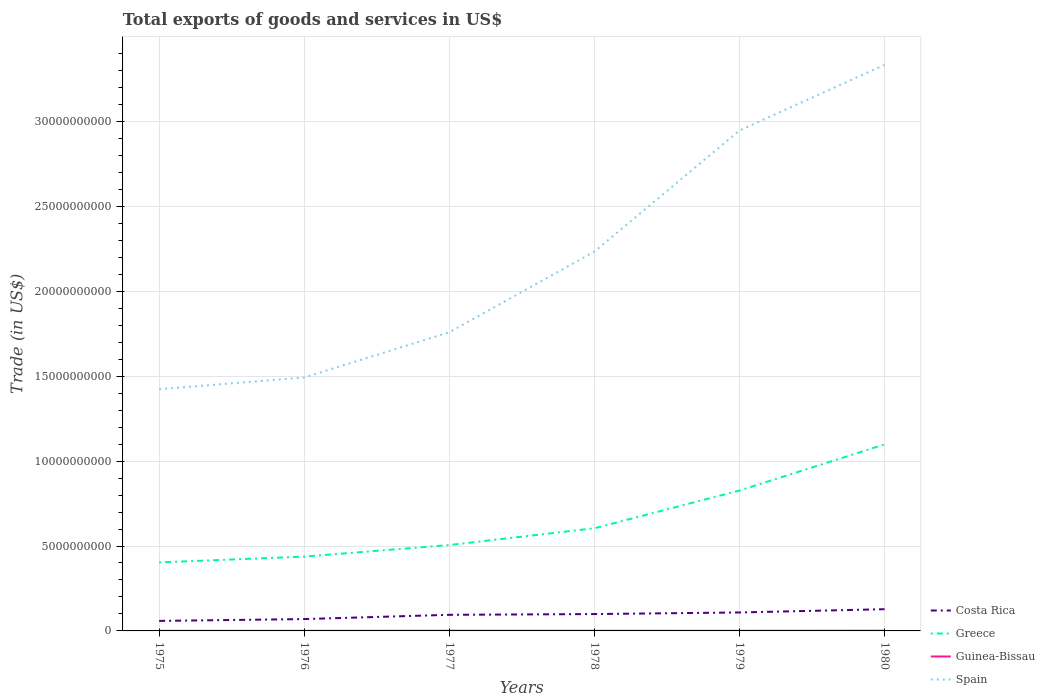Does the line corresponding to Costa Rica intersect with the line corresponding to Spain?
Provide a short and direct response. No. Across all years, what is the maximum total exports of goods and services in Costa Rica?
Offer a very short reply. 5.89e+08. In which year was the total exports of goods and services in Costa Rica maximum?
Offer a terse response. 1975. What is the total total exports of goods and services in Greece in the graph?
Provide a succinct answer. -3.43e+08. What is the difference between the highest and the second highest total exports of goods and services in Guinea-Bissau?
Your answer should be very brief. 8.39e+06. How many years are there in the graph?
Provide a short and direct response. 6. Are the values on the major ticks of Y-axis written in scientific E-notation?
Offer a very short reply. No. Does the graph contain any zero values?
Your answer should be very brief. No. Where does the legend appear in the graph?
Provide a succinct answer. Bottom right. How many legend labels are there?
Ensure brevity in your answer.  4. How are the legend labels stacked?
Provide a succinct answer. Vertical. What is the title of the graph?
Provide a short and direct response. Total exports of goods and services in US$. Does "Isle of Man" appear as one of the legend labels in the graph?
Provide a short and direct response. No. What is the label or title of the Y-axis?
Provide a short and direct response. Trade (in US$). What is the Trade (in US$) in Costa Rica in 1975?
Your answer should be very brief. 5.89e+08. What is the Trade (in US$) in Greece in 1975?
Make the answer very short. 4.03e+09. What is the Trade (in US$) in Guinea-Bissau in 1975?
Offer a terse response. 5.65e+06. What is the Trade (in US$) in Spain in 1975?
Ensure brevity in your answer.  1.42e+1. What is the Trade (in US$) of Costa Rica in 1976?
Your answer should be very brief. 6.97e+08. What is the Trade (in US$) of Greece in 1976?
Ensure brevity in your answer.  4.38e+09. What is the Trade (in US$) in Guinea-Bissau in 1976?
Your response must be concise. 5.93e+06. What is the Trade (in US$) of Spain in 1976?
Make the answer very short. 1.49e+1. What is the Trade (in US$) in Costa Rica in 1977?
Ensure brevity in your answer.  9.48e+08. What is the Trade (in US$) of Greece in 1977?
Make the answer very short. 5.06e+09. What is the Trade (in US$) of Guinea-Bissau in 1977?
Provide a short and direct response. 1.07e+07. What is the Trade (in US$) in Spain in 1977?
Ensure brevity in your answer.  1.76e+1. What is the Trade (in US$) of Costa Rica in 1978?
Your answer should be very brief. 9.93e+08. What is the Trade (in US$) of Greece in 1978?
Keep it short and to the point. 6.04e+09. What is the Trade (in US$) of Guinea-Bissau in 1978?
Provide a short and direct response. 9.49e+06. What is the Trade (in US$) of Spain in 1978?
Offer a terse response. 2.23e+1. What is the Trade (in US$) of Costa Rica in 1979?
Keep it short and to the point. 1.09e+09. What is the Trade (in US$) in Greece in 1979?
Offer a very short reply. 8.27e+09. What is the Trade (in US$) in Guinea-Bissau in 1979?
Offer a terse response. 8.62e+06. What is the Trade (in US$) of Spain in 1979?
Keep it short and to the point. 2.95e+1. What is the Trade (in US$) of Costa Rica in 1980?
Provide a succinct answer. 1.28e+09. What is the Trade (in US$) in Greece in 1980?
Provide a succinct answer. 1.10e+1. What is the Trade (in US$) in Guinea-Bissau in 1980?
Ensure brevity in your answer.  1.40e+07. What is the Trade (in US$) of Spain in 1980?
Your answer should be compact. 3.33e+1. Across all years, what is the maximum Trade (in US$) in Costa Rica?
Your response must be concise. 1.28e+09. Across all years, what is the maximum Trade (in US$) of Greece?
Provide a succinct answer. 1.10e+1. Across all years, what is the maximum Trade (in US$) in Guinea-Bissau?
Make the answer very short. 1.40e+07. Across all years, what is the maximum Trade (in US$) in Spain?
Ensure brevity in your answer.  3.33e+1. Across all years, what is the minimum Trade (in US$) of Costa Rica?
Ensure brevity in your answer.  5.89e+08. Across all years, what is the minimum Trade (in US$) of Greece?
Your answer should be compact. 4.03e+09. Across all years, what is the minimum Trade (in US$) of Guinea-Bissau?
Keep it short and to the point. 5.65e+06. Across all years, what is the minimum Trade (in US$) of Spain?
Your answer should be compact. 1.42e+1. What is the total Trade (in US$) in Costa Rica in the graph?
Your answer should be very brief. 5.59e+09. What is the total Trade (in US$) in Greece in the graph?
Give a very brief answer. 3.88e+1. What is the total Trade (in US$) in Guinea-Bissau in the graph?
Provide a succinct answer. 5.44e+07. What is the total Trade (in US$) in Spain in the graph?
Provide a succinct answer. 1.32e+11. What is the difference between the Trade (in US$) of Costa Rica in 1975 and that in 1976?
Give a very brief answer. -1.08e+08. What is the difference between the Trade (in US$) of Greece in 1975 and that in 1976?
Provide a succinct answer. -3.43e+08. What is the difference between the Trade (in US$) in Guinea-Bissau in 1975 and that in 1976?
Make the answer very short. -2.75e+05. What is the difference between the Trade (in US$) of Spain in 1975 and that in 1976?
Give a very brief answer. -6.89e+08. What is the difference between the Trade (in US$) in Costa Rica in 1975 and that in 1977?
Keep it short and to the point. -3.59e+08. What is the difference between the Trade (in US$) in Greece in 1975 and that in 1977?
Offer a terse response. -1.02e+09. What is the difference between the Trade (in US$) of Guinea-Bissau in 1975 and that in 1977?
Your response must be concise. -5.05e+06. What is the difference between the Trade (in US$) in Spain in 1975 and that in 1977?
Offer a terse response. -3.35e+09. What is the difference between the Trade (in US$) in Costa Rica in 1975 and that in 1978?
Keep it short and to the point. -4.03e+08. What is the difference between the Trade (in US$) in Greece in 1975 and that in 1978?
Provide a succinct answer. -2.01e+09. What is the difference between the Trade (in US$) in Guinea-Bissau in 1975 and that in 1978?
Your answer should be very brief. -3.84e+06. What is the difference between the Trade (in US$) in Spain in 1975 and that in 1978?
Provide a short and direct response. -8.10e+09. What is the difference between the Trade (in US$) of Costa Rica in 1975 and that in 1979?
Offer a terse response. -4.97e+08. What is the difference between the Trade (in US$) in Greece in 1975 and that in 1979?
Provide a short and direct response. -4.23e+09. What is the difference between the Trade (in US$) of Guinea-Bissau in 1975 and that in 1979?
Offer a very short reply. -2.97e+06. What is the difference between the Trade (in US$) in Spain in 1975 and that in 1979?
Provide a short and direct response. -1.52e+1. What is the difference between the Trade (in US$) of Costa Rica in 1975 and that in 1980?
Offer a terse response. -6.90e+08. What is the difference between the Trade (in US$) in Greece in 1975 and that in 1980?
Keep it short and to the point. -6.95e+09. What is the difference between the Trade (in US$) of Guinea-Bissau in 1975 and that in 1980?
Provide a succinct answer. -8.39e+06. What is the difference between the Trade (in US$) of Spain in 1975 and that in 1980?
Your answer should be compact. -1.91e+1. What is the difference between the Trade (in US$) of Costa Rica in 1976 and that in 1977?
Provide a short and direct response. -2.51e+08. What is the difference between the Trade (in US$) of Greece in 1976 and that in 1977?
Offer a very short reply. -6.81e+08. What is the difference between the Trade (in US$) of Guinea-Bissau in 1976 and that in 1977?
Provide a succinct answer. -4.77e+06. What is the difference between the Trade (in US$) in Spain in 1976 and that in 1977?
Provide a short and direct response. -2.66e+09. What is the difference between the Trade (in US$) in Costa Rica in 1976 and that in 1978?
Provide a succinct answer. -2.95e+08. What is the difference between the Trade (in US$) in Greece in 1976 and that in 1978?
Offer a terse response. -1.67e+09. What is the difference between the Trade (in US$) of Guinea-Bissau in 1976 and that in 1978?
Give a very brief answer. -3.56e+06. What is the difference between the Trade (in US$) of Spain in 1976 and that in 1978?
Provide a succinct answer. -7.41e+09. What is the difference between the Trade (in US$) of Costa Rica in 1976 and that in 1979?
Your response must be concise. -3.89e+08. What is the difference between the Trade (in US$) in Greece in 1976 and that in 1979?
Your answer should be very brief. -3.89e+09. What is the difference between the Trade (in US$) of Guinea-Bissau in 1976 and that in 1979?
Offer a terse response. -2.69e+06. What is the difference between the Trade (in US$) in Spain in 1976 and that in 1979?
Ensure brevity in your answer.  -1.45e+1. What is the difference between the Trade (in US$) of Costa Rica in 1976 and that in 1980?
Your answer should be compact. -5.82e+08. What is the difference between the Trade (in US$) of Greece in 1976 and that in 1980?
Offer a very short reply. -6.61e+09. What is the difference between the Trade (in US$) of Guinea-Bissau in 1976 and that in 1980?
Keep it short and to the point. -8.11e+06. What is the difference between the Trade (in US$) in Spain in 1976 and that in 1980?
Make the answer very short. -1.84e+1. What is the difference between the Trade (in US$) in Costa Rica in 1977 and that in 1978?
Give a very brief answer. -4.45e+07. What is the difference between the Trade (in US$) in Greece in 1977 and that in 1978?
Your answer should be compact. -9.87e+08. What is the difference between the Trade (in US$) of Guinea-Bissau in 1977 and that in 1978?
Keep it short and to the point. 1.21e+06. What is the difference between the Trade (in US$) in Spain in 1977 and that in 1978?
Make the answer very short. -4.75e+09. What is the difference between the Trade (in US$) of Costa Rica in 1977 and that in 1979?
Offer a terse response. -1.38e+08. What is the difference between the Trade (in US$) in Greece in 1977 and that in 1979?
Your answer should be compact. -3.21e+09. What is the difference between the Trade (in US$) of Guinea-Bissau in 1977 and that in 1979?
Make the answer very short. 2.08e+06. What is the difference between the Trade (in US$) in Spain in 1977 and that in 1979?
Give a very brief answer. -1.19e+1. What is the difference between the Trade (in US$) in Costa Rica in 1977 and that in 1980?
Your answer should be very brief. -3.31e+08. What is the difference between the Trade (in US$) in Greece in 1977 and that in 1980?
Your answer should be very brief. -5.92e+09. What is the difference between the Trade (in US$) of Guinea-Bissau in 1977 and that in 1980?
Provide a succinct answer. -3.34e+06. What is the difference between the Trade (in US$) of Spain in 1977 and that in 1980?
Make the answer very short. -1.57e+1. What is the difference between the Trade (in US$) in Costa Rica in 1978 and that in 1979?
Your response must be concise. -9.36e+07. What is the difference between the Trade (in US$) in Greece in 1978 and that in 1979?
Your answer should be compact. -2.22e+09. What is the difference between the Trade (in US$) of Guinea-Bissau in 1978 and that in 1979?
Ensure brevity in your answer.  8.68e+05. What is the difference between the Trade (in US$) of Spain in 1978 and that in 1979?
Offer a very short reply. -7.13e+09. What is the difference between the Trade (in US$) in Costa Rica in 1978 and that in 1980?
Provide a succinct answer. -2.86e+08. What is the difference between the Trade (in US$) of Greece in 1978 and that in 1980?
Your response must be concise. -4.94e+09. What is the difference between the Trade (in US$) of Guinea-Bissau in 1978 and that in 1980?
Give a very brief answer. -4.55e+06. What is the difference between the Trade (in US$) of Spain in 1978 and that in 1980?
Your response must be concise. -1.10e+1. What is the difference between the Trade (in US$) in Costa Rica in 1979 and that in 1980?
Your answer should be compact. -1.93e+08. What is the difference between the Trade (in US$) of Greece in 1979 and that in 1980?
Your answer should be compact. -2.71e+09. What is the difference between the Trade (in US$) in Guinea-Bissau in 1979 and that in 1980?
Your answer should be very brief. -5.42e+06. What is the difference between the Trade (in US$) in Spain in 1979 and that in 1980?
Provide a succinct answer. -3.86e+09. What is the difference between the Trade (in US$) in Costa Rica in 1975 and the Trade (in US$) in Greece in 1976?
Your answer should be compact. -3.79e+09. What is the difference between the Trade (in US$) of Costa Rica in 1975 and the Trade (in US$) of Guinea-Bissau in 1976?
Your answer should be very brief. 5.84e+08. What is the difference between the Trade (in US$) in Costa Rica in 1975 and the Trade (in US$) in Spain in 1976?
Keep it short and to the point. -1.43e+1. What is the difference between the Trade (in US$) in Greece in 1975 and the Trade (in US$) in Guinea-Bissau in 1976?
Offer a terse response. 4.03e+09. What is the difference between the Trade (in US$) in Greece in 1975 and the Trade (in US$) in Spain in 1976?
Offer a very short reply. -1.09e+1. What is the difference between the Trade (in US$) in Guinea-Bissau in 1975 and the Trade (in US$) in Spain in 1976?
Give a very brief answer. -1.49e+1. What is the difference between the Trade (in US$) of Costa Rica in 1975 and the Trade (in US$) of Greece in 1977?
Offer a very short reply. -4.47e+09. What is the difference between the Trade (in US$) of Costa Rica in 1975 and the Trade (in US$) of Guinea-Bissau in 1977?
Your answer should be very brief. 5.79e+08. What is the difference between the Trade (in US$) in Costa Rica in 1975 and the Trade (in US$) in Spain in 1977?
Make the answer very short. -1.70e+1. What is the difference between the Trade (in US$) in Greece in 1975 and the Trade (in US$) in Guinea-Bissau in 1977?
Offer a terse response. 4.02e+09. What is the difference between the Trade (in US$) of Greece in 1975 and the Trade (in US$) of Spain in 1977?
Give a very brief answer. -1.36e+1. What is the difference between the Trade (in US$) of Guinea-Bissau in 1975 and the Trade (in US$) of Spain in 1977?
Provide a short and direct response. -1.76e+1. What is the difference between the Trade (in US$) of Costa Rica in 1975 and the Trade (in US$) of Greece in 1978?
Offer a terse response. -5.45e+09. What is the difference between the Trade (in US$) in Costa Rica in 1975 and the Trade (in US$) in Guinea-Bissau in 1978?
Your answer should be very brief. 5.80e+08. What is the difference between the Trade (in US$) in Costa Rica in 1975 and the Trade (in US$) in Spain in 1978?
Make the answer very short. -2.17e+1. What is the difference between the Trade (in US$) of Greece in 1975 and the Trade (in US$) of Guinea-Bissau in 1978?
Your answer should be very brief. 4.02e+09. What is the difference between the Trade (in US$) in Greece in 1975 and the Trade (in US$) in Spain in 1978?
Offer a very short reply. -1.83e+1. What is the difference between the Trade (in US$) in Guinea-Bissau in 1975 and the Trade (in US$) in Spain in 1978?
Keep it short and to the point. -2.23e+1. What is the difference between the Trade (in US$) of Costa Rica in 1975 and the Trade (in US$) of Greece in 1979?
Offer a very short reply. -7.68e+09. What is the difference between the Trade (in US$) in Costa Rica in 1975 and the Trade (in US$) in Guinea-Bissau in 1979?
Your answer should be compact. 5.81e+08. What is the difference between the Trade (in US$) of Costa Rica in 1975 and the Trade (in US$) of Spain in 1979?
Provide a short and direct response. -2.89e+1. What is the difference between the Trade (in US$) in Greece in 1975 and the Trade (in US$) in Guinea-Bissau in 1979?
Offer a very short reply. 4.03e+09. What is the difference between the Trade (in US$) of Greece in 1975 and the Trade (in US$) of Spain in 1979?
Give a very brief answer. -2.54e+1. What is the difference between the Trade (in US$) of Guinea-Bissau in 1975 and the Trade (in US$) of Spain in 1979?
Provide a short and direct response. -2.95e+1. What is the difference between the Trade (in US$) in Costa Rica in 1975 and the Trade (in US$) in Greece in 1980?
Provide a short and direct response. -1.04e+1. What is the difference between the Trade (in US$) of Costa Rica in 1975 and the Trade (in US$) of Guinea-Bissau in 1980?
Your response must be concise. 5.75e+08. What is the difference between the Trade (in US$) of Costa Rica in 1975 and the Trade (in US$) of Spain in 1980?
Provide a short and direct response. -3.27e+1. What is the difference between the Trade (in US$) in Greece in 1975 and the Trade (in US$) in Guinea-Bissau in 1980?
Provide a short and direct response. 4.02e+09. What is the difference between the Trade (in US$) of Greece in 1975 and the Trade (in US$) of Spain in 1980?
Give a very brief answer. -2.93e+1. What is the difference between the Trade (in US$) in Guinea-Bissau in 1975 and the Trade (in US$) in Spain in 1980?
Your answer should be very brief. -3.33e+1. What is the difference between the Trade (in US$) in Costa Rica in 1976 and the Trade (in US$) in Greece in 1977?
Your answer should be very brief. -4.36e+09. What is the difference between the Trade (in US$) in Costa Rica in 1976 and the Trade (in US$) in Guinea-Bissau in 1977?
Offer a very short reply. 6.87e+08. What is the difference between the Trade (in US$) of Costa Rica in 1976 and the Trade (in US$) of Spain in 1977?
Offer a very short reply. -1.69e+1. What is the difference between the Trade (in US$) in Greece in 1976 and the Trade (in US$) in Guinea-Bissau in 1977?
Give a very brief answer. 4.37e+09. What is the difference between the Trade (in US$) of Greece in 1976 and the Trade (in US$) of Spain in 1977?
Make the answer very short. -1.32e+1. What is the difference between the Trade (in US$) of Guinea-Bissau in 1976 and the Trade (in US$) of Spain in 1977?
Ensure brevity in your answer.  -1.76e+1. What is the difference between the Trade (in US$) in Costa Rica in 1976 and the Trade (in US$) in Greece in 1978?
Make the answer very short. -5.35e+09. What is the difference between the Trade (in US$) in Costa Rica in 1976 and the Trade (in US$) in Guinea-Bissau in 1978?
Keep it short and to the point. 6.88e+08. What is the difference between the Trade (in US$) of Costa Rica in 1976 and the Trade (in US$) of Spain in 1978?
Offer a very short reply. -2.16e+1. What is the difference between the Trade (in US$) in Greece in 1976 and the Trade (in US$) in Guinea-Bissau in 1978?
Keep it short and to the point. 4.37e+09. What is the difference between the Trade (in US$) in Greece in 1976 and the Trade (in US$) in Spain in 1978?
Your answer should be very brief. -1.80e+1. What is the difference between the Trade (in US$) in Guinea-Bissau in 1976 and the Trade (in US$) in Spain in 1978?
Your answer should be very brief. -2.23e+1. What is the difference between the Trade (in US$) in Costa Rica in 1976 and the Trade (in US$) in Greece in 1979?
Provide a succinct answer. -7.57e+09. What is the difference between the Trade (in US$) in Costa Rica in 1976 and the Trade (in US$) in Guinea-Bissau in 1979?
Offer a terse response. 6.89e+08. What is the difference between the Trade (in US$) in Costa Rica in 1976 and the Trade (in US$) in Spain in 1979?
Keep it short and to the point. -2.88e+1. What is the difference between the Trade (in US$) in Greece in 1976 and the Trade (in US$) in Guinea-Bissau in 1979?
Make the answer very short. 4.37e+09. What is the difference between the Trade (in US$) in Greece in 1976 and the Trade (in US$) in Spain in 1979?
Your answer should be compact. -2.51e+1. What is the difference between the Trade (in US$) in Guinea-Bissau in 1976 and the Trade (in US$) in Spain in 1979?
Your answer should be compact. -2.95e+1. What is the difference between the Trade (in US$) of Costa Rica in 1976 and the Trade (in US$) of Greece in 1980?
Provide a succinct answer. -1.03e+1. What is the difference between the Trade (in US$) in Costa Rica in 1976 and the Trade (in US$) in Guinea-Bissau in 1980?
Provide a succinct answer. 6.83e+08. What is the difference between the Trade (in US$) of Costa Rica in 1976 and the Trade (in US$) of Spain in 1980?
Your answer should be very brief. -3.26e+1. What is the difference between the Trade (in US$) of Greece in 1976 and the Trade (in US$) of Guinea-Bissau in 1980?
Offer a terse response. 4.36e+09. What is the difference between the Trade (in US$) in Greece in 1976 and the Trade (in US$) in Spain in 1980?
Your answer should be compact. -2.90e+1. What is the difference between the Trade (in US$) of Guinea-Bissau in 1976 and the Trade (in US$) of Spain in 1980?
Your response must be concise. -3.33e+1. What is the difference between the Trade (in US$) in Costa Rica in 1977 and the Trade (in US$) in Greece in 1978?
Your response must be concise. -5.10e+09. What is the difference between the Trade (in US$) in Costa Rica in 1977 and the Trade (in US$) in Guinea-Bissau in 1978?
Make the answer very short. 9.39e+08. What is the difference between the Trade (in US$) of Costa Rica in 1977 and the Trade (in US$) of Spain in 1978?
Provide a short and direct response. -2.14e+1. What is the difference between the Trade (in US$) of Greece in 1977 and the Trade (in US$) of Guinea-Bissau in 1978?
Give a very brief answer. 5.05e+09. What is the difference between the Trade (in US$) of Greece in 1977 and the Trade (in US$) of Spain in 1978?
Give a very brief answer. -1.73e+1. What is the difference between the Trade (in US$) of Guinea-Bissau in 1977 and the Trade (in US$) of Spain in 1978?
Offer a very short reply. -2.23e+1. What is the difference between the Trade (in US$) of Costa Rica in 1977 and the Trade (in US$) of Greece in 1979?
Give a very brief answer. -7.32e+09. What is the difference between the Trade (in US$) of Costa Rica in 1977 and the Trade (in US$) of Guinea-Bissau in 1979?
Your answer should be compact. 9.40e+08. What is the difference between the Trade (in US$) in Costa Rica in 1977 and the Trade (in US$) in Spain in 1979?
Your response must be concise. -2.85e+1. What is the difference between the Trade (in US$) in Greece in 1977 and the Trade (in US$) in Guinea-Bissau in 1979?
Ensure brevity in your answer.  5.05e+09. What is the difference between the Trade (in US$) of Greece in 1977 and the Trade (in US$) of Spain in 1979?
Your response must be concise. -2.44e+1. What is the difference between the Trade (in US$) in Guinea-Bissau in 1977 and the Trade (in US$) in Spain in 1979?
Give a very brief answer. -2.95e+1. What is the difference between the Trade (in US$) in Costa Rica in 1977 and the Trade (in US$) in Greece in 1980?
Provide a succinct answer. -1.00e+1. What is the difference between the Trade (in US$) of Costa Rica in 1977 and the Trade (in US$) of Guinea-Bissau in 1980?
Give a very brief answer. 9.34e+08. What is the difference between the Trade (in US$) in Costa Rica in 1977 and the Trade (in US$) in Spain in 1980?
Your answer should be compact. -3.24e+1. What is the difference between the Trade (in US$) of Greece in 1977 and the Trade (in US$) of Guinea-Bissau in 1980?
Provide a short and direct response. 5.04e+09. What is the difference between the Trade (in US$) in Greece in 1977 and the Trade (in US$) in Spain in 1980?
Offer a terse response. -2.83e+1. What is the difference between the Trade (in US$) in Guinea-Bissau in 1977 and the Trade (in US$) in Spain in 1980?
Ensure brevity in your answer.  -3.33e+1. What is the difference between the Trade (in US$) of Costa Rica in 1978 and the Trade (in US$) of Greece in 1979?
Your answer should be compact. -7.27e+09. What is the difference between the Trade (in US$) in Costa Rica in 1978 and the Trade (in US$) in Guinea-Bissau in 1979?
Ensure brevity in your answer.  9.84e+08. What is the difference between the Trade (in US$) of Costa Rica in 1978 and the Trade (in US$) of Spain in 1979?
Your response must be concise. -2.85e+1. What is the difference between the Trade (in US$) of Greece in 1978 and the Trade (in US$) of Guinea-Bissau in 1979?
Ensure brevity in your answer.  6.04e+09. What is the difference between the Trade (in US$) of Greece in 1978 and the Trade (in US$) of Spain in 1979?
Provide a succinct answer. -2.34e+1. What is the difference between the Trade (in US$) of Guinea-Bissau in 1978 and the Trade (in US$) of Spain in 1979?
Provide a short and direct response. -2.95e+1. What is the difference between the Trade (in US$) in Costa Rica in 1978 and the Trade (in US$) in Greece in 1980?
Your answer should be very brief. -9.99e+09. What is the difference between the Trade (in US$) of Costa Rica in 1978 and the Trade (in US$) of Guinea-Bissau in 1980?
Offer a very short reply. 9.79e+08. What is the difference between the Trade (in US$) in Costa Rica in 1978 and the Trade (in US$) in Spain in 1980?
Offer a very short reply. -3.23e+1. What is the difference between the Trade (in US$) in Greece in 1978 and the Trade (in US$) in Guinea-Bissau in 1980?
Your response must be concise. 6.03e+09. What is the difference between the Trade (in US$) in Greece in 1978 and the Trade (in US$) in Spain in 1980?
Your response must be concise. -2.73e+1. What is the difference between the Trade (in US$) in Guinea-Bissau in 1978 and the Trade (in US$) in Spain in 1980?
Keep it short and to the point. -3.33e+1. What is the difference between the Trade (in US$) of Costa Rica in 1979 and the Trade (in US$) of Greece in 1980?
Your response must be concise. -9.90e+09. What is the difference between the Trade (in US$) of Costa Rica in 1979 and the Trade (in US$) of Guinea-Bissau in 1980?
Give a very brief answer. 1.07e+09. What is the difference between the Trade (in US$) in Costa Rica in 1979 and the Trade (in US$) in Spain in 1980?
Provide a short and direct response. -3.22e+1. What is the difference between the Trade (in US$) in Greece in 1979 and the Trade (in US$) in Guinea-Bissau in 1980?
Give a very brief answer. 8.25e+09. What is the difference between the Trade (in US$) of Greece in 1979 and the Trade (in US$) of Spain in 1980?
Offer a terse response. -2.51e+1. What is the difference between the Trade (in US$) in Guinea-Bissau in 1979 and the Trade (in US$) in Spain in 1980?
Make the answer very short. -3.33e+1. What is the average Trade (in US$) in Costa Rica per year?
Offer a terse response. 9.32e+08. What is the average Trade (in US$) in Greece per year?
Your answer should be compact. 6.46e+09. What is the average Trade (in US$) of Guinea-Bissau per year?
Your response must be concise. 9.07e+06. What is the average Trade (in US$) in Spain per year?
Your response must be concise. 2.20e+1. In the year 1975, what is the difference between the Trade (in US$) in Costa Rica and Trade (in US$) in Greece?
Your response must be concise. -3.44e+09. In the year 1975, what is the difference between the Trade (in US$) in Costa Rica and Trade (in US$) in Guinea-Bissau?
Your answer should be very brief. 5.84e+08. In the year 1975, what is the difference between the Trade (in US$) of Costa Rica and Trade (in US$) of Spain?
Offer a very short reply. -1.36e+1. In the year 1975, what is the difference between the Trade (in US$) of Greece and Trade (in US$) of Guinea-Bissau?
Your response must be concise. 4.03e+09. In the year 1975, what is the difference between the Trade (in US$) of Greece and Trade (in US$) of Spain?
Provide a short and direct response. -1.02e+1. In the year 1975, what is the difference between the Trade (in US$) of Guinea-Bissau and Trade (in US$) of Spain?
Keep it short and to the point. -1.42e+1. In the year 1976, what is the difference between the Trade (in US$) in Costa Rica and Trade (in US$) in Greece?
Keep it short and to the point. -3.68e+09. In the year 1976, what is the difference between the Trade (in US$) of Costa Rica and Trade (in US$) of Guinea-Bissau?
Give a very brief answer. 6.92e+08. In the year 1976, what is the difference between the Trade (in US$) of Costa Rica and Trade (in US$) of Spain?
Provide a short and direct response. -1.42e+1. In the year 1976, what is the difference between the Trade (in US$) in Greece and Trade (in US$) in Guinea-Bissau?
Your response must be concise. 4.37e+09. In the year 1976, what is the difference between the Trade (in US$) of Greece and Trade (in US$) of Spain?
Offer a terse response. -1.05e+1. In the year 1976, what is the difference between the Trade (in US$) of Guinea-Bissau and Trade (in US$) of Spain?
Provide a short and direct response. -1.49e+1. In the year 1977, what is the difference between the Trade (in US$) of Costa Rica and Trade (in US$) of Greece?
Ensure brevity in your answer.  -4.11e+09. In the year 1977, what is the difference between the Trade (in US$) in Costa Rica and Trade (in US$) in Guinea-Bissau?
Provide a succinct answer. 9.38e+08. In the year 1977, what is the difference between the Trade (in US$) of Costa Rica and Trade (in US$) of Spain?
Provide a succinct answer. -1.66e+1. In the year 1977, what is the difference between the Trade (in US$) of Greece and Trade (in US$) of Guinea-Bissau?
Provide a succinct answer. 5.05e+09. In the year 1977, what is the difference between the Trade (in US$) in Greece and Trade (in US$) in Spain?
Make the answer very short. -1.25e+1. In the year 1977, what is the difference between the Trade (in US$) in Guinea-Bissau and Trade (in US$) in Spain?
Your response must be concise. -1.76e+1. In the year 1978, what is the difference between the Trade (in US$) of Costa Rica and Trade (in US$) of Greece?
Your response must be concise. -5.05e+09. In the year 1978, what is the difference between the Trade (in US$) in Costa Rica and Trade (in US$) in Guinea-Bissau?
Provide a succinct answer. 9.83e+08. In the year 1978, what is the difference between the Trade (in US$) of Costa Rica and Trade (in US$) of Spain?
Keep it short and to the point. -2.13e+1. In the year 1978, what is the difference between the Trade (in US$) of Greece and Trade (in US$) of Guinea-Bissau?
Your response must be concise. 6.03e+09. In the year 1978, what is the difference between the Trade (in US$) of Greece and Trade (in US$) of Spain?
Your response must be concise. -1.63e+1. In the year 1978, what is the difference between the Trade (in US$) of Guinea-Bissau and Trade (in US$) of Spain?
Provide a succinct answer. -2.23e+1. In the year 1979, what is the difference between the Trade (in US$) in Costa Rica and Trade (in US$) in Greece?
Offer a terse response. -7.18e+09. In the year 1979, what is the difference between the Trade (in US$) in Costa Rica and Trade (in US$) in Guinea-Bissau?
Provide a succinct answer. 1.08e+09. In the year 1979, what is the difference between the Trade (in US$) of Costa Rica and Trade (in US$) of Spain?
Your answer should be very brief. -2.84e+1. In the year 1979, what is the difference between the Trade (in US$) in Greece and Trade (in US$) in Guinea-Bissau?
Offer a terse response. 8.26e+09. In the year 1979, what is the difference between the Trade (in US$) in Greece and Trade (in US$) in Spain?
Provide a short and direct response. -2.12e+1. In the year 1979, what is the difference between the Trade (in US$) of Guinea-Bissau and Trade (in US$) of Spain?
Your response must be concise. -2.95e+1. In the year 1980, what is the difference between the Trade (in US$) of Costa Rica and Trade (in US$) of Greece?
Offer a terse response. -9.70e+09. In the year 1980, what is the difference between the Trade (in US$) of Costa Rica and Trade (in US$) of Guinea-Bissau?
Your response must be concise. 1.27e+09. In the year 1980, what is the difference between the Trade (in US$) in Costa Rica and Trade (in US$) in Spain?
Offer a very short reply. -3.21e+1. In the year 1980, what is the difference between the Trade (in US$) in Greece and Trade (in US$) in Guinea-Bissau?
Offer a very short reply. 1.10e+1. In the year 1980, what is the difference between the Trade (in US$) in Greece and Trade (in US$) in Spain?
Offer a terse response. -2.24e+1. In the year 1980, what is the difference between the Trade (in US$) in Guinea-Bissau and Trade (in US$) in Spain?
Offer a very short reply. -3.33e+1. What is the ratio of the Trade (in US$) of Costa Rica in 1975 to that in 1976?
Ensure brevity in your answer.  0.85. What is the ratio of the Trade (in US$) in Greece in 1975 to that in 1976?
Offer a very short reply. 0.92. What is the ratio of the Trade (in US$) in Guinea-Bissau in 1975 to that in 1976?
Offer a terse response. 0.95. What is the ratio of the Trade (in US$) of Spain in 1975 to that in 1976?
Give a very brief answer. 0.95. What is the ratio of the Trade (in US$) of Costa Rica in 1975 to that in 1977?
Keep it short and to the point. 0.62. What is the ratio of the Trade (in US$) of Greece in 1975 to that in 1977?
Your answer should be compact. 0.8. What is the ratio of the Trade (in US$) in Guinea-Bissau in 1975 to that in 1977?
Ensure brevity in your answer.  0.53. What is the ratio of the Trade (in US$) in Spain in 1975 to that in 1977?
Your answer should be compact. 0.81. What is the ratio of the Trade (in US$) in Costa Rica in 1975 to that in 1978?
Your response must be concise. 0.59. What is the ratio of the Trade (in US$) of Greece in 1975 to that in 1978?
Your response must be concise. 0.67. What is the ratio of the Trade (in US$) of Guinea-Bissau in 1975 to that in 1978?
Provide a short and direct response. 0.6. What is the ratio of the Trade (in US$) in Spain in 1975 to that in 1978?
Your answer should be compact. 0.64. What is the ratio of the Trade (in US$) in Costa Rica in 1975 to that in 1979?
Keep it short and to the point. 0.54. What is the ratio of the Trade (in US$) in Greece in 1975 to that in 1979?
Provide a short and direct response. 0.49. What is the ratio of the Trade (in US$) in Guinea-Bissau in 1975 to that in 1979?
Make the answer very short. 0.66. What is the ratio of the Trade (in US$) in Spain in 1975 to that in 1979?
Provide a succinct answer. 0.48. What is the ratio of the Trade (in US$) in Costa Rica in 1975 to that in 1980?
Provide a short and direct response. 0.46. What is the ratio of the Trade (in US$) of Greece in 1975 to that in 1980?
Provide a short and direct response. 0.37. What is the ratio of the Trade (in US$) of Guinea-Bissau in 1975 to that in 1980?
Give a very brief answer. 0.4. What is the ratio of the Trade (in US$) of Spain in 1975 to that in 1980?
Offer a terse response. 0.43. What is the ratio of the Trade (in US$) in Costa Rica in 1976 to that in 1977?
Your answer should be compact. 0.74. What is the ratio of the Trade (in US$) in Greece in 1976 to that in 1977?
Ensure brevity in your answer.  0.87. What is the ratio of the Trade (in US$) in Guinea-Bissau in 1976 to that in 1977?
Offer a very short reply. 0.55. What is the ratio of the Trade (in US$) of Spain in 1976 to that in 1977?
Offer a very short reply. 0.85. What is the ratio of the Trade (in US$) of Costa Rica in 1976 to that in 1978?
Provide a succinct answer. 0.7. What is the ratio of the Trade (in US$) of Greece in 1976 to that in 1978?
Make the answer very short. 0.72. What is the ratio of the Trade (in US$) of Guinea-Bissau in 1976 to that in 1978?
Offer a terse response. 0.62. What is the ratio of the Trade (in US$) in Spain in 1976 to that in 1978?
Your response must be concise. 0.67. What is the ratio of the Trade (in US$) of Costa Rica in 1976 to that in 1979?
Your answer should be compact. 0.64. What is the ratio of the Trade (in US$) of Greece in 1976 to that in 1979?
Your response must be concise. 0.53. What is the ratio of the Trade (in US$) in Guinea-Bissau in 1976 to that in 1979?
Your response must be concise. 0.69. What is the ratio of the Trade (in US$) in Spain in 1976 to that in 1979?
Give a very brief answer. 0.51. What is the ratio of the Trade (in US$) in Costa Rica in 1976 to that in 1980?
Make the answer very short. 0.55. What is the ratio of the Trade (in US$) of Greece in 1976 to that in 1980?
Your answer should be very brief. 0.4. What is the ratio of the Trade (in US$) in Guinea-Bissau in 1976 to that in 1980?
Offer a terse response. 0.42. What is the ratio of the Trade (in US$) of Spain in 1976 to that in 1980?
Provide a succinct answer. 0.45. What is the ratio of the Trade (in US$) of Costa Rica in 1977 to that in 1978?
Your answer should be compact. 0.96. What is the ratio of the Trade (in US$) in Greece in 1977 to that in 1978?
Your answer should be very brief. 0.84. What is the ratio of the Trade (in US$) in Guinea-Bissau in 1977 to that in 1978?
Give a very brief answer. 1.13. What is the ratio of the Trade (in US$) of Spain in 1977 to that in 1978?
Give a very brief answer. 0.79. What is the ratio of the Trade (in US$) in Costa Rica in 1977 to that in 1979?
Offer a very short reply. 0.87. What is the ratio of the Trade (in US$) in Greece in 1977 to that in 1979?
Give a very brief answer. 0.61. What is the ratio of the Trade (in US$) of Guinea-Bissau in 1977 to that in 1979?
Offer a terse response. 1.24. What is the ratio of the Trade (in US$) of Spain in 1977 to that in 1979?
Keep it short and to the point. 0.6. What is the ratio of the Trade (in US$) of Costa Rica in 1977 to that in 1980?
Offer a terse response. 0.74. What is the ratio of the Trade (in US$) of Greece in 1977 to that in 1980?
Make the answer very short. 0.46. What is the ratio of the Trade (in US$) in Guinea-Bissau in 1977 to that in 1980?
Your answer should be compact. 0.76. What is the ratio of the Trade (in US$) of Spain in 1977 to that in 1980?
Your answer should be compact. 0.53. What is the ratio of the Trade (in US$) of Costa Rica in 1978 to that in 1979?
Ensure brevity in your answer.  0.91. What is the ratio of the Trade (in US$) in Greece in 1978 to that in 1979?
Your answer should be very brief. 0.73. What is the ratio of the Trade (in US$) of Guinea-Bissau in 1978 to that in 1979?
Ensure brevity in your answer.  1.1. What is the ratio of the Trade (in US$) of Spain in 1978 to that in 1979?
Ensure brevity in your answer.  0.76. What is the ratio of the Trade (in US$) of Costa Rica in 1978 to that in 1980?
Keep it short and to the point. 0.78. What is the ratio of the Trade (in US$) of Greece in 1978 to that in 1980?
Ensure brevity in your answer.  0.55. What is the ratio of the Trade (in US$) in Guinea-Bissau in 1978 to that in 1980?
Offer a very short reply. 0.68. What is the ratio of the Trade (in US$) in Spain in 1978 to that in 1980?
Keep it short and to the point. 0.67. What is the ratio of the Trade (in US$) in Costa Rica in 1979 to that in 1980?
Ensure brevity in your answer.  0.85. What is the ratio of the Trade (in US$) in Greece in 1979 to that in 1980?
Your response must be concise. 0.75. What is the ratio of the Trade (in US$) in Guinea-Bissau in 1979 to that in 1980?
Provide a short and direct response. 0.61. What is the ratio of the Trade (in US$) of Spain in 1979 to that in 1980?
Provide a short and direct response. 0.88. What is the difference between the highest and the second highest Trade (in US$) in Costa Rica?
Provide a short and direct response. 1.93e+08. What is the difference between the highest and the second highest Trade (in US$) of Greece?
Your answer should be very brief. 2.71e+09. What is the difference between the highest and the second highest Trade (in US$) of Guinea-Bissau?
Your answer should be very brief. 3.34e+06. What is the difference between the highest and the second highest Trade (in US$) in Spain?
Your answer should be compact. 3.86e+09. What is the difference between the highest and the lowest Trade (in US$) of Costa Rica?
Offer a terse response. 6.90e+08. What is the difference between the highest and the lowest Trade (in US$) in Greece?
Give a very brief answer. 6.95e+09. What is the difference between the highest and the lowest Trade (in US$) in Guinea-Bissau?
Offer a very short reply. 8.39e+06. What is the difference between the highest and the lowest Trade (in US$) of Spain?
Provide a succinct answer. 1.91e+1. 